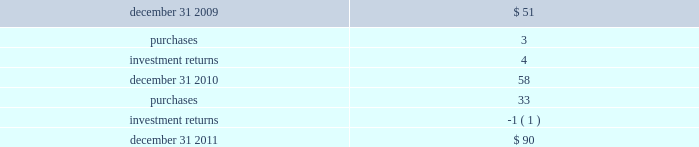Devon energy corporation and subsidiaries notes to consolidated financial statements 2014 ( continued ) the following methods and assumptions were used to estimate the fair values in the tables above .
Fixed-income securities 2014 devon 2019s fixed-income securities consist of u.s .
Treasury obligations , bonds issued by investment-grade companies from diverse industries , and asset-backed securities .
These fixed-income securities are actively traded securities that can be redeemed upon demand .
The fair values of these level 1 securities are based upon quoted market prices .
Devon 2019s fixed income securities also include commingled funds that primarily invest in long-term bonds and u.s .
Treasury securities .
These fixed income securities can be redeemed on demand but are not actively traded .
The fair values of these level 2 securities are based upon the net asset values provided by the investment managers .
Equity securities 2014 devon 2019s equity securities include a commingled global equity fund that invests in large , mid and small capitalization stocks across the world 2019s developed and emerging markets .
These equity securities can be redeemed on demand but are not actively traded .
The fair values of these level 2 securities are based upon the net asset values provided by the investment managers .
At december 31 , 2010 , devon 2019s equity securities consisted of investments in u.s .
Large and small capitalization companies and international large capitalization companies .
These equity securities were actively traded securities that could be redeemed upon demand .
The fair values of these level 1 securities are based upon quoted market prices .
At december 31 , 2010 , devon 2019s equity securities also included a commingled fund that invested in large capitalization companies .
These equity securities could be redeemed on demand but were not actively traded .
The fair values of these level 2 securities are based upon the net asset values provided by the investment managers .
Other securities 2014 devon 2019s other securities include commingled , short-term investment funds .
These securities can be redeemed on demand but are not actively traded .
The fair values of these level 2 securities are based upon the net asset values provided by investment managers .
Devon 2019s hedge fund and alternative investments include an investment in an actively traded global mutual fund that focuses on alternative investment strategies and a hedge fund of funds that invests both long and short using a variety of investment strategies .
Devon 2019s hedge fund of funds is not actively traded and devon is subject to redemption restrictions with regards to this investment .
The fair value of this level 3 investment represents the fair value as determined by the hedge fund manager .
Included below is a summary of the changes in devon 2019s level 3 plan assets ( in millions ) . .

What was the percentage change in devon 2019s level 3 plan assets from 2009 to 2010? 
Computations: ((58 - 51) / 51)
Answer: 0.13725. 